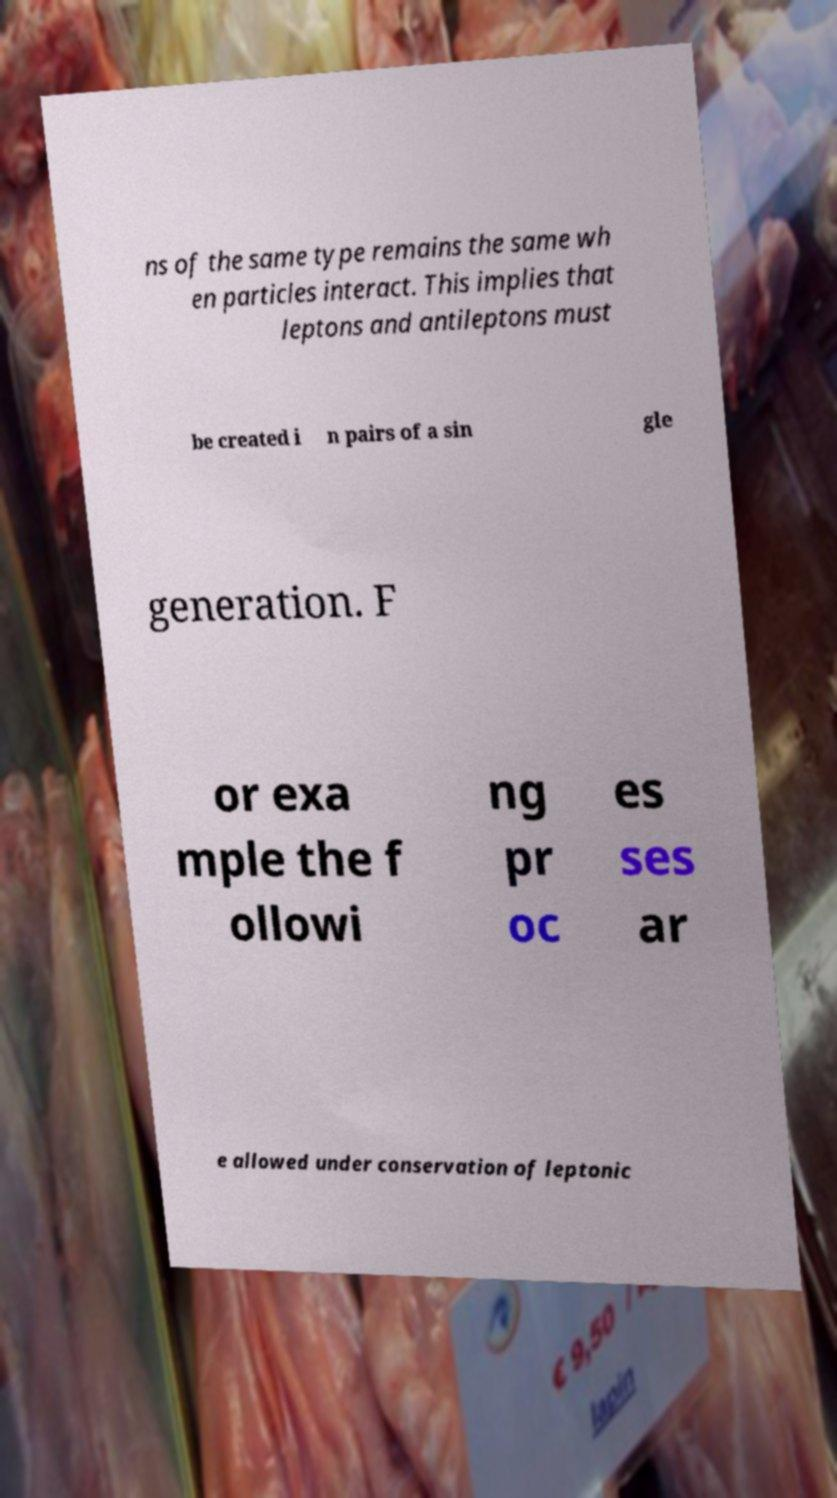I need the written content from this picture converted into text. Can you do that? ns of the same type remains the same wh en particles interact. This implies that leptons and antileptons must be created i n pairs of a sin gle generation. F or exa mple the f ollowi ng pr oc es ses ar e allowed under conservation of leptonic 